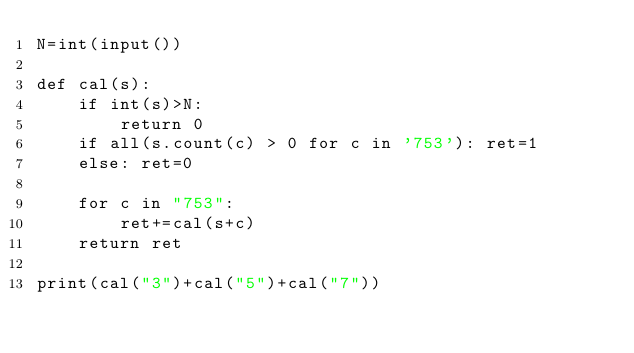Convert code to text. <code><loc_0><loc_0><loc_500><loc_500><_Python_>N=int(input())

def cal(s):
    if int(s)>N:
        return 0
    if all(s.count(c) > 0 for c in '753'): ret=1
    else: ret=0
    
    for c in "753":
        ret+=cal(s+c)
    return ret

print(cal("3")+cal("5")+cal("7"))</code> 